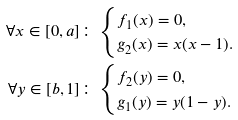Convert formula to latex. <formula><loc_0><loc_0><loc_500><loc_500>\forall x \in [ 0 , a ] \colon & \begin{cases} f _ { 1 } ( x ) = 0 , \\ g _ { 2 } ( x ) = x ( x - 1 ) . \end{cases} \\ \forall y \in [ b , 1 ] \colon & \begin{cases} f _ { 2 } ( y ) = 0 , \\ g _ { 1 } ( y ) = y ( 1 - y ) . \end{cases}</formula> 